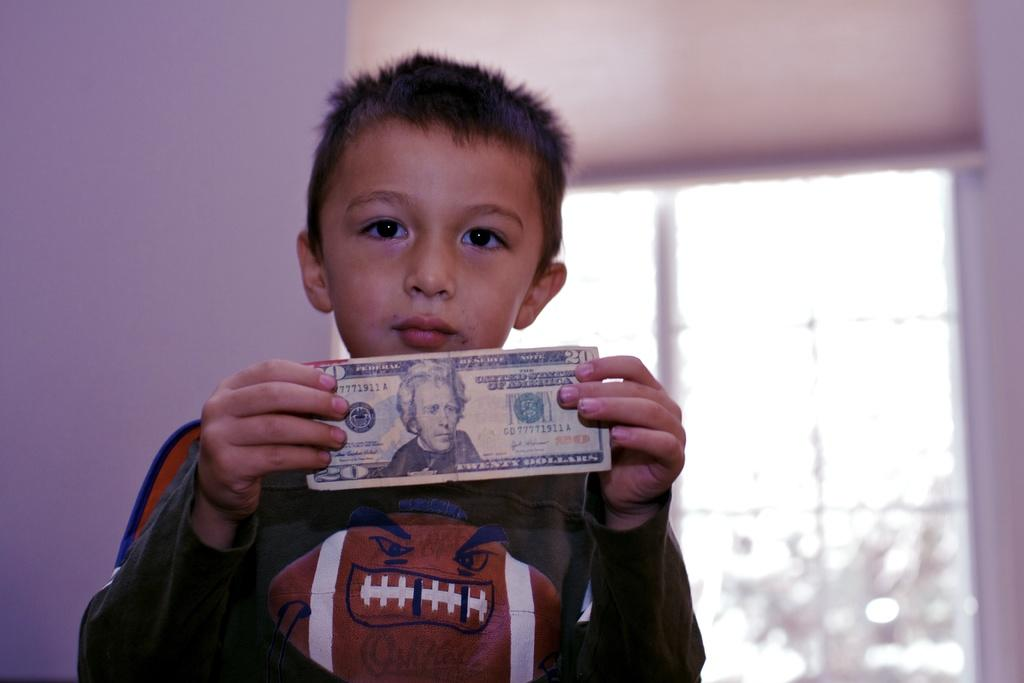<image>
Render a clear and concise summary of the photo. A young boy holds up a twenty dollar bill with United States of America printed on it 